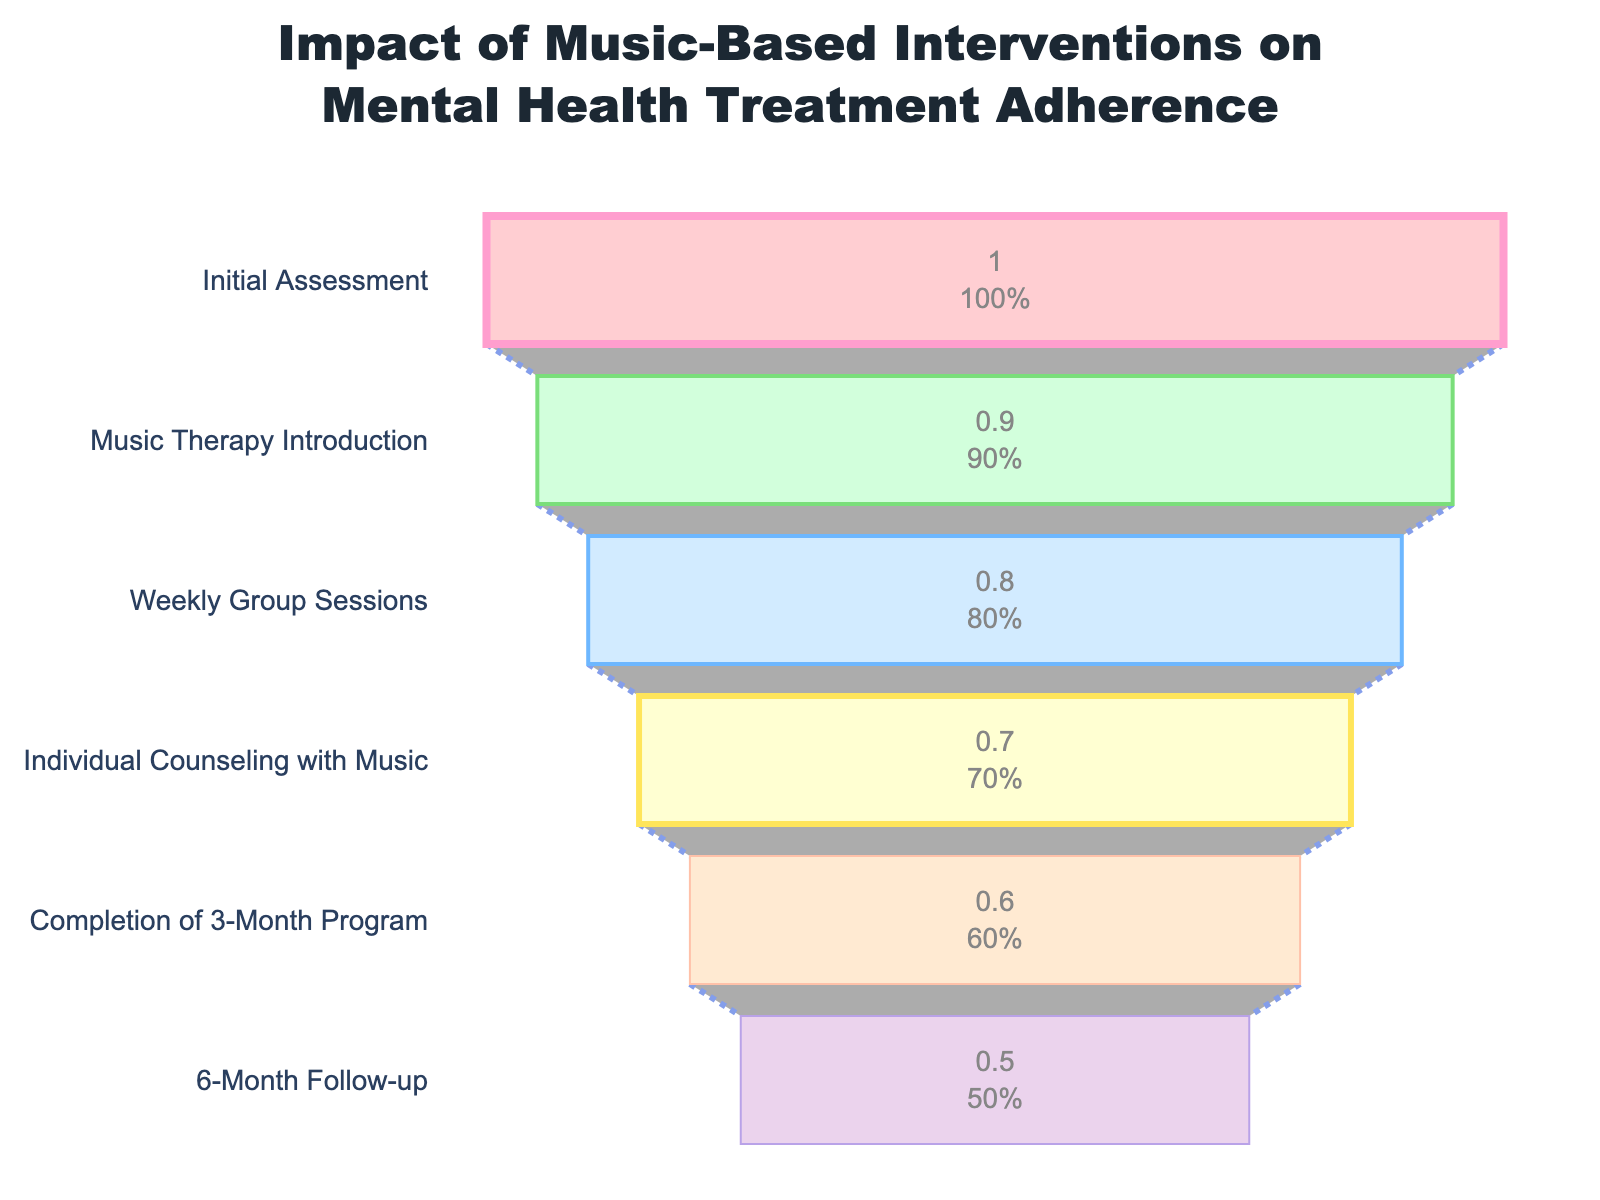What's the title of the chart? The title is located at the top center of the chart; it is descriptive of the content presented.
Answer: Impact of Music-Based Interventions on Mental Health Treatment Adherence How many stages are depicted in the funnel chart? Count the number of different stages listed on the y-axis.
Answer: 6 What is the adherence rate at the Weekly Group Sessions stage? Locate the Weekly Group Sessions stage on the y-axis and refer to its corresponding adherence rate.
Answer: 80% By what percentage does the adherence rate drop from the Initial Assessment to the Completion of the 3-Month Program? Subtract the adherence rate at the Completion of the 3-Month Program (60%) from the adherence rate at the Initial Assessment (100%).
Answer: 40% Which stage has the highest drop in adherence rate compared to the previous stage? Calculate the drop in adherence rate between each consecutive stage and identify the largest drop. The adherence rates are: Initial Assessment (100%) to Music Therapy Introduction (90%) = 10%, Music Therapy Introduction (90%) to Weekly Group Sessions (80%) = 10%, Weekly Group Sessions (80%) to Individual Counseling with Music (70%) = 10%, Individual Counseling with Music (70%) to Completion of 3-Month Program (60%) = 10%, Completion of the 3-Month Program (60%) to 6-Month Follow-up (50%) = 10%. All drops are equal.
Answer: None (they are all 10%) What color represents the Individual Counseling with Music stage? Observe the color-coded stages in the funnel chart and identify the color for the Individual Counseling with Music stage.
Answer: Light blue Which stage follows the Weekly Group Sessions stage in the treatment plan? Check the sequence of stages listed on the y-axis and find the stage that comes after Weekly Group Sessions.
Answer: Individual Counseling with Music What is the total percentage drop in adherence from the Initial Assessment to the 6-Month Follow-up stage? Subtract the adherence rate at the 6-Month Follow-up (50%) from the adherence rate at the Initial Assessment (100%).
Answer: 50% What is the average adherence rate across all stages presented in the funnel chart? Sum all of the adherence rates (100% + 90% + 80% + 70% + 60% + 50%) and divide by the number of stages (6). The average is (100% + 90% + 80% + 70% + 60% + 50%) / 6 = 75%.
Answer: 75% 